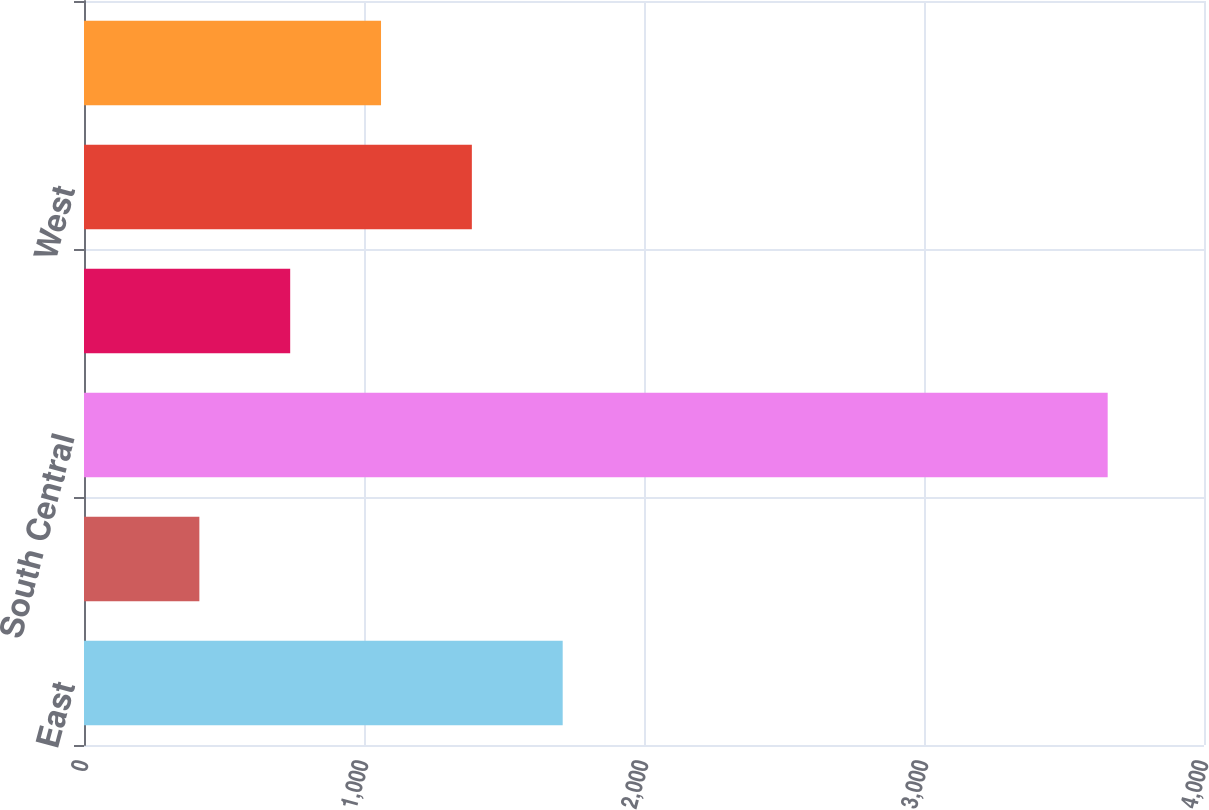<chart> <loc_0><loc_0><loc_500><loc_500><bar_chart><fcel>East<fcel>Midwest<fcel>South Central<fcel>Southwest<fcel>West<fcel>Southeast<nl><fcel>1709.6<fcel>412<fcel>3656<fcel>736.4<fcel>1385.2<fcel>1060.8<nl></chart> 